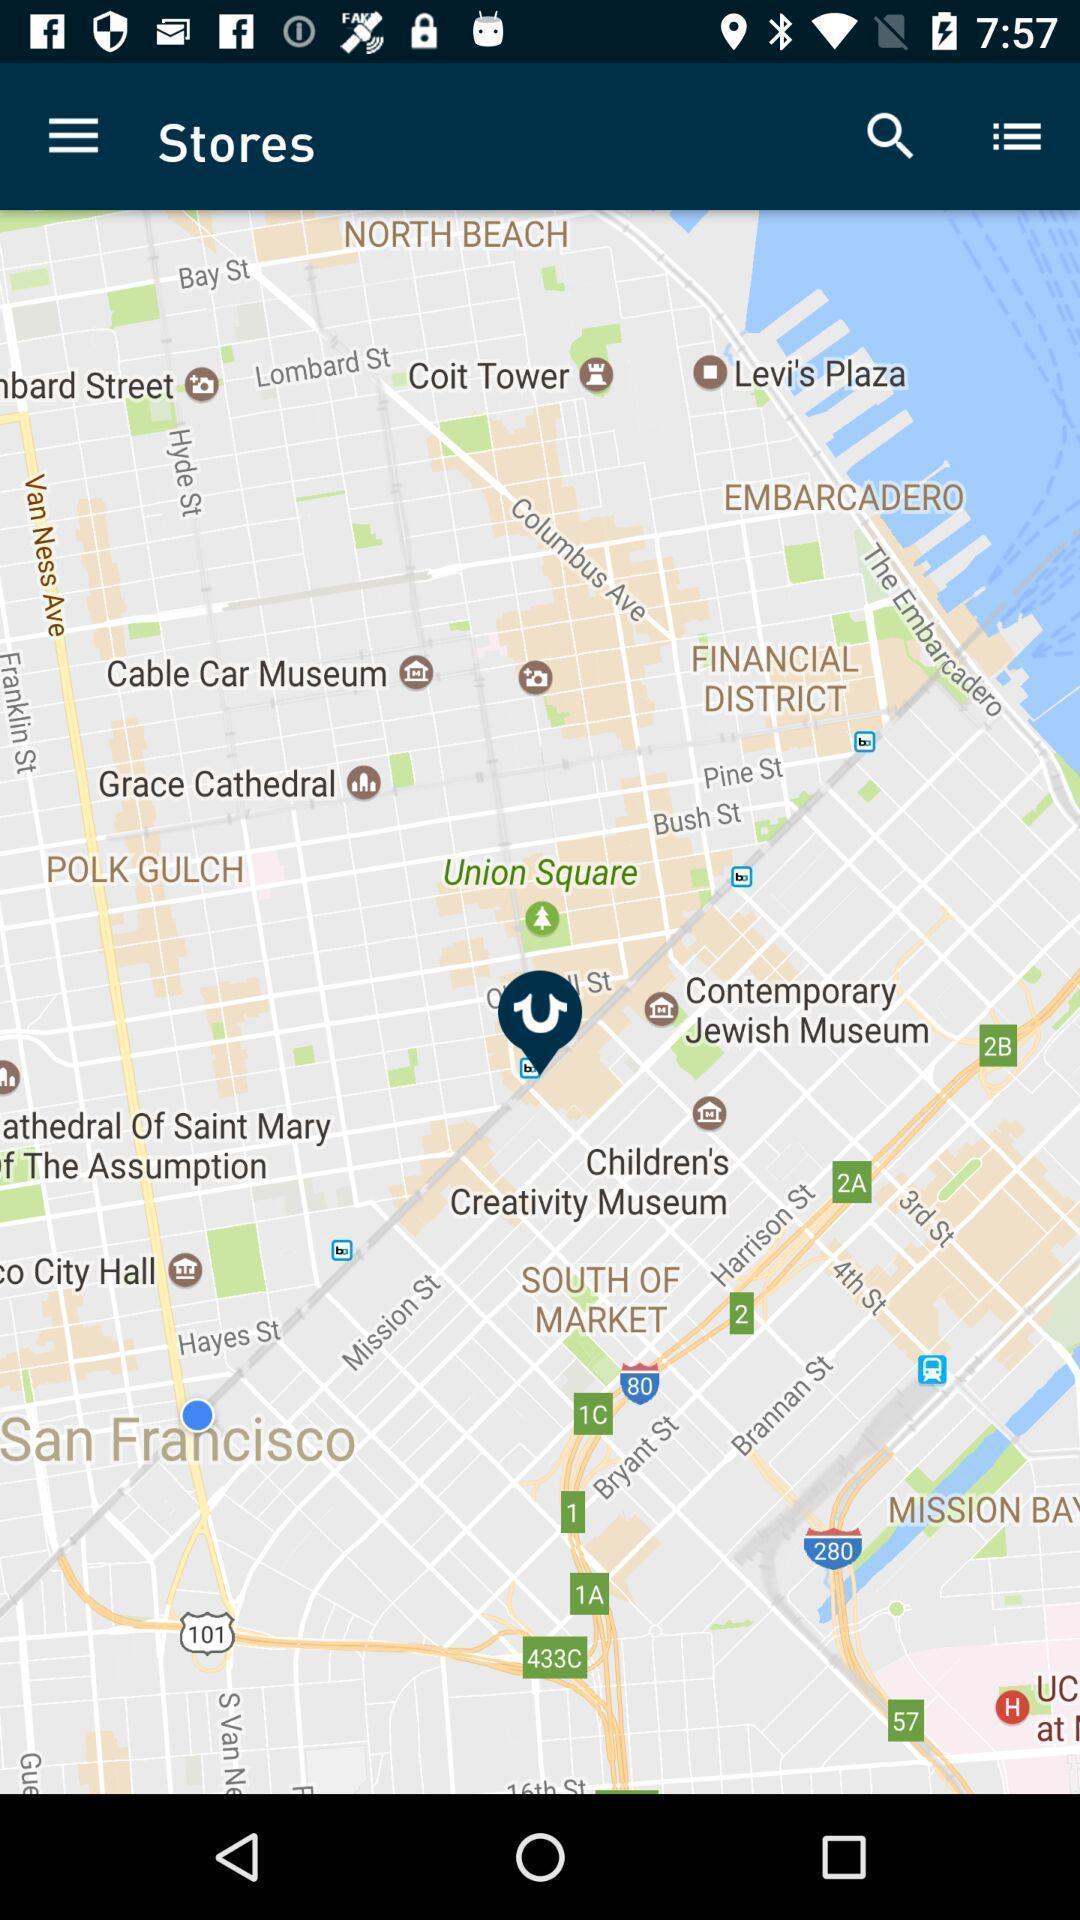Describe the content in this image. Page that displaying a map. 